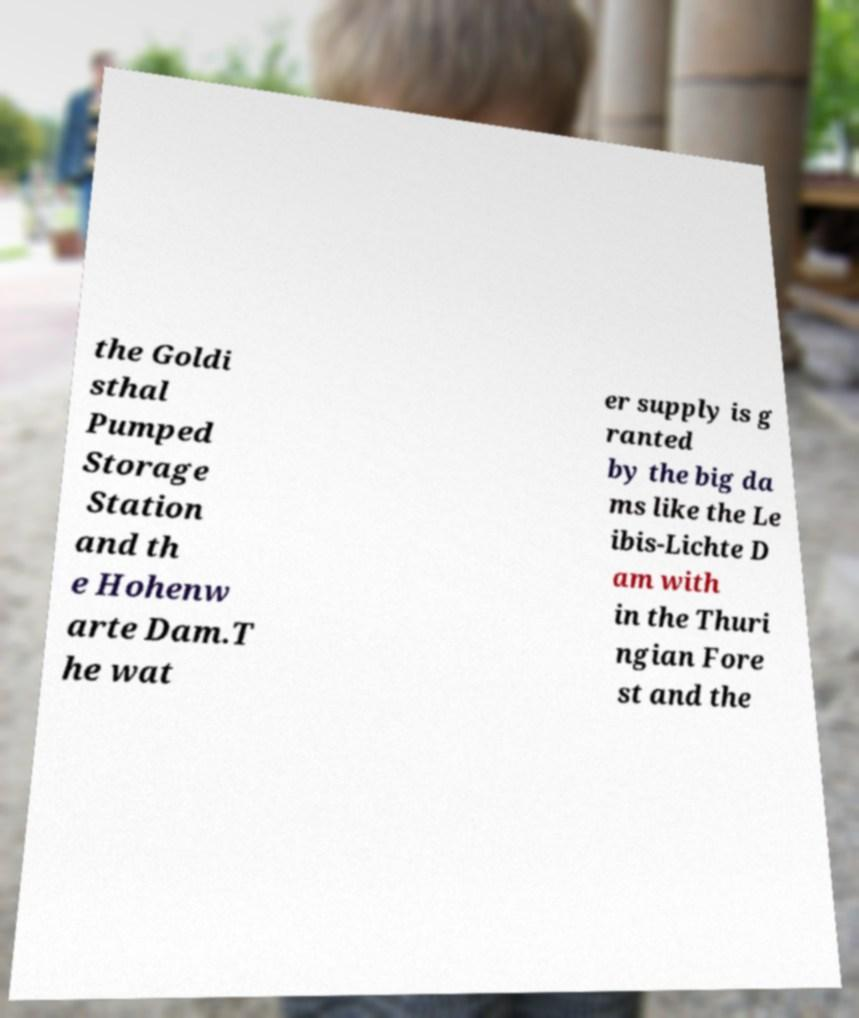There's text embedded in this image that I need extracted. Can you transcribe it verbatim? the Goldi sthal Pumped Storage Station and th e Hohenw arte Dam.T he wat er supply is g ranted by the big da ms like the Le ibis-Lichte D am with in the Thuri ngian Fore st and the 